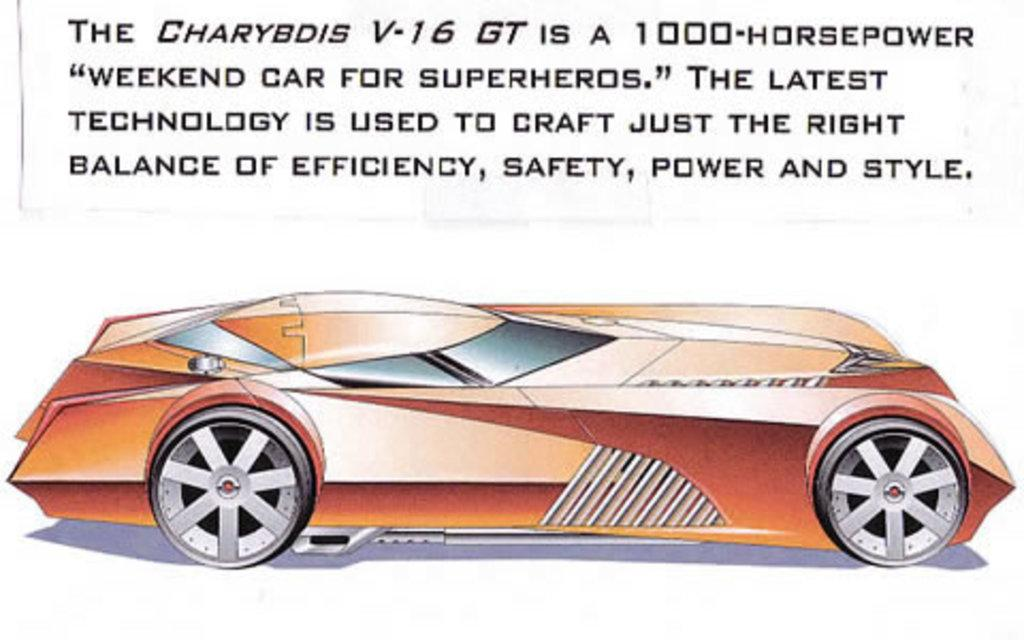What is featured in the picture? There is a poster in the picture. What can be found at the top of the picture? There is text at the top of the picture. What type of image is on the poster? There is a cartoon picture of a car on the poster. How many trains are depicted on the poster? There are no trains depicted on the poster; it features a cartoon picture of a car. What type of ornament is hanging from the top of the picture? There is no ornament present in the image; it only features a poster with text and a cartoon picture of a car. 